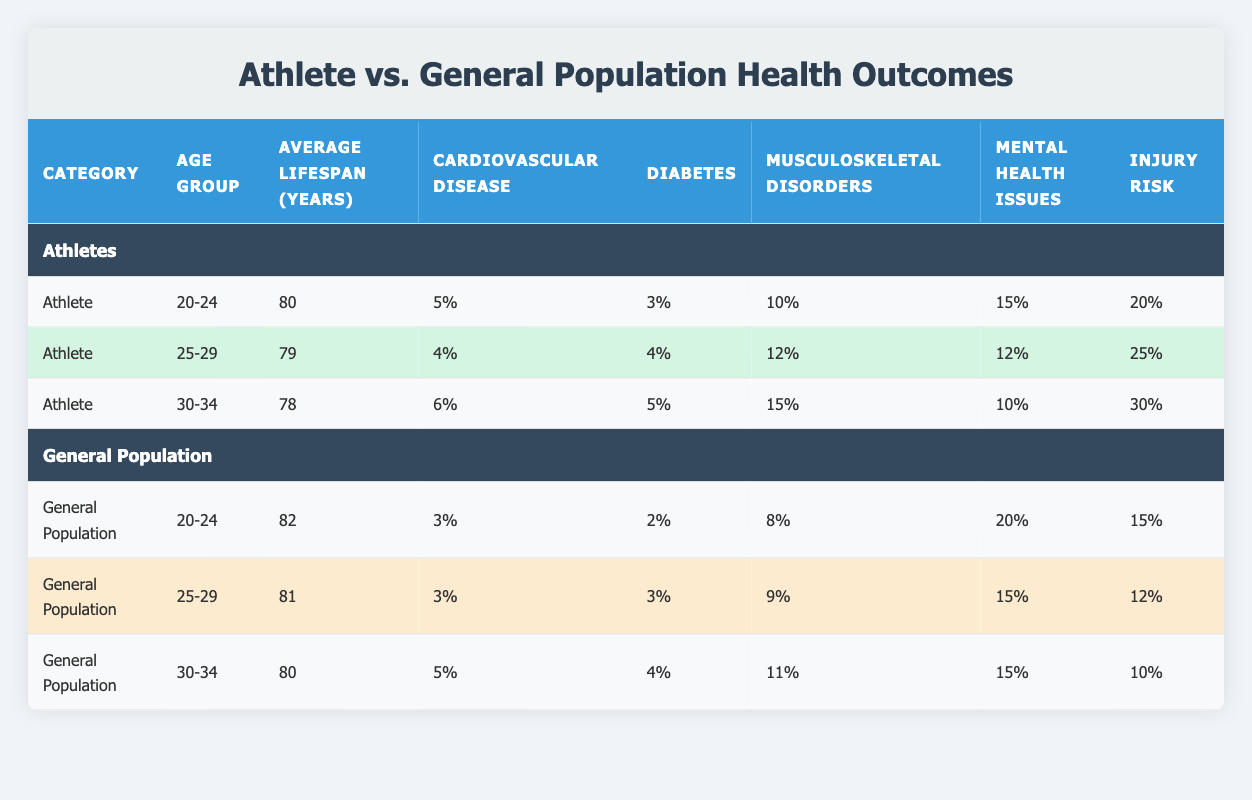What is the average lifespan of athletes aged 25-29? According to the table, the average lifespan of athletes aged 25-29 is listed directly in the "Average Lifespan (Years)" column, which is 79 years.
Answer: 79 What percentage of athletes aged 30-34 have musculoskeletal disorders? The table indicates that 15% of the athletes aged 30-34 have musculoskeletal disorders, as found in the respective row under the "Musculoskeletal Disorders" column.
Answer: 15% Is the injury risk higher for athletes aged 20-24 compared to the general population in the same age group? Athletes aged 20-24 have an injury risk of 20%, while the general population in the same age group has an injury risk of 15%. Since 20% is greater than 15%, the statement is true.
Answer: Yes Compare the average lifespan of the general population and athletes aged 30-34. The average lifespan for athletes aged 30-34 is 78 years, while for the general population in the same age group it is 80 years. Thus, the general population lives 2 years longer. The calculations are: 80 - 78 = 2.
Answer: 2 years What is the combined percentage of chronic conditions for athletes aged 20-24? For athletes aged 20-24, the chronic conditions are: cardiovascular disease (5%), diabetes (3%), and musculoskeletal disorders (10%). Adding these percentages gives: 5% + 3% + 10% = 18%.
Answer: 18% Are mental health issues more prevalent in the general population aged 25-29 than in athletes of the same age group? Athletes aged 25-29 have a prevalence of mental health issues at 12%, while the general population has a prevalence of 15%. Since 15% is greater than 12%, the statement is true.
Answer: Yes What is the difference in the percentage of diabetes between athletes aged 25-29 and the general population in the same age group? Athletes aged 25-29 have a diabetes rate of 4%, while the general population has a diabetes rate of 3%. The difference is calculated as follows: 4% - 3% = 1%.
Answer: 1% Which age group among athletes has the highest injury risk? The injury risk data shows that athletes aged 30-34 have the highest injury risk at 30%. This is the maximum value listed in the "Injury Risk" column for athletes, confirming they have the highest risk.
Answer: 30% 